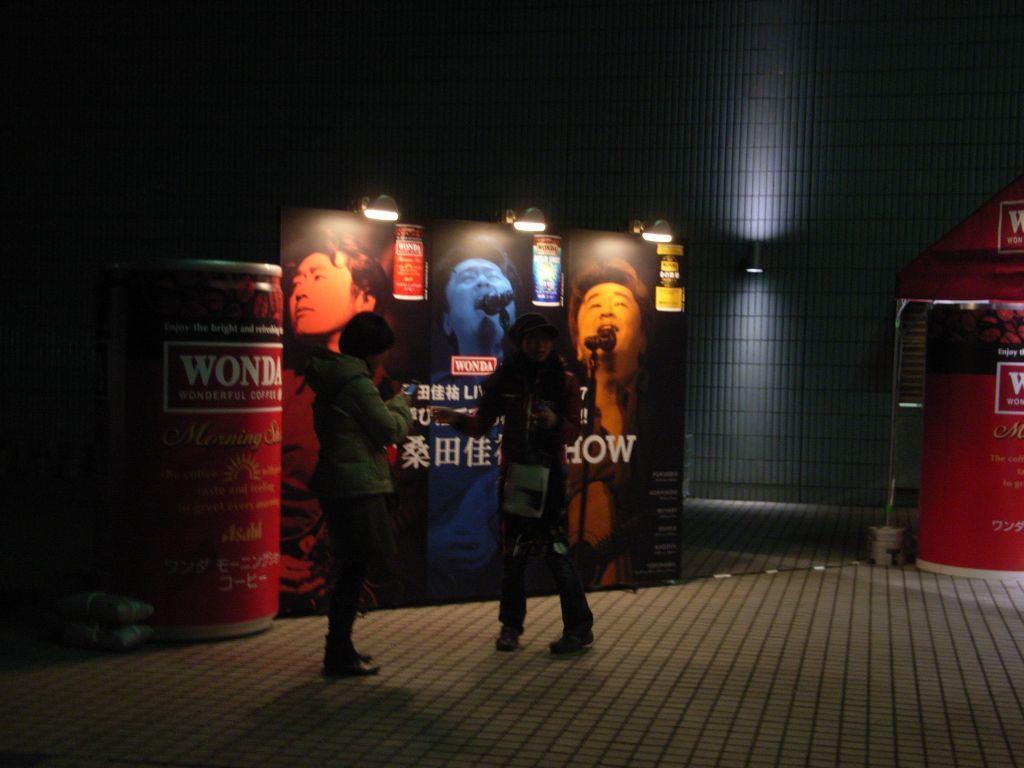Describe this image in one or two sentences. In this image, we can see two people are standing on the floor. Background we can see a banner, some objects, stall, wall, lights. In the banner, we can see few people with microphones. 